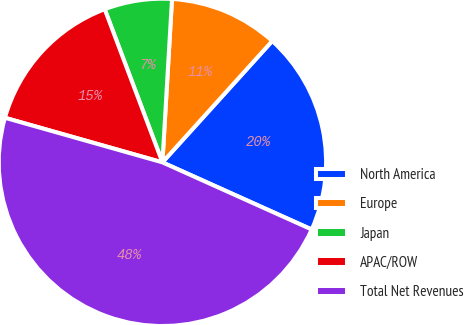Convert chart. <chart><loc_0><loc_0><loc_500><loc_500><pie_chart><fcel>North America<fcel>Europe<fcel>Japan<fcel>APAC/ROW<fcel>Total Net Revenues<nl><fcel>20.02%<fcel>10.77%<fcel>6.67%<fcel>14.87%<fcel>47.66%<nl></chart> 